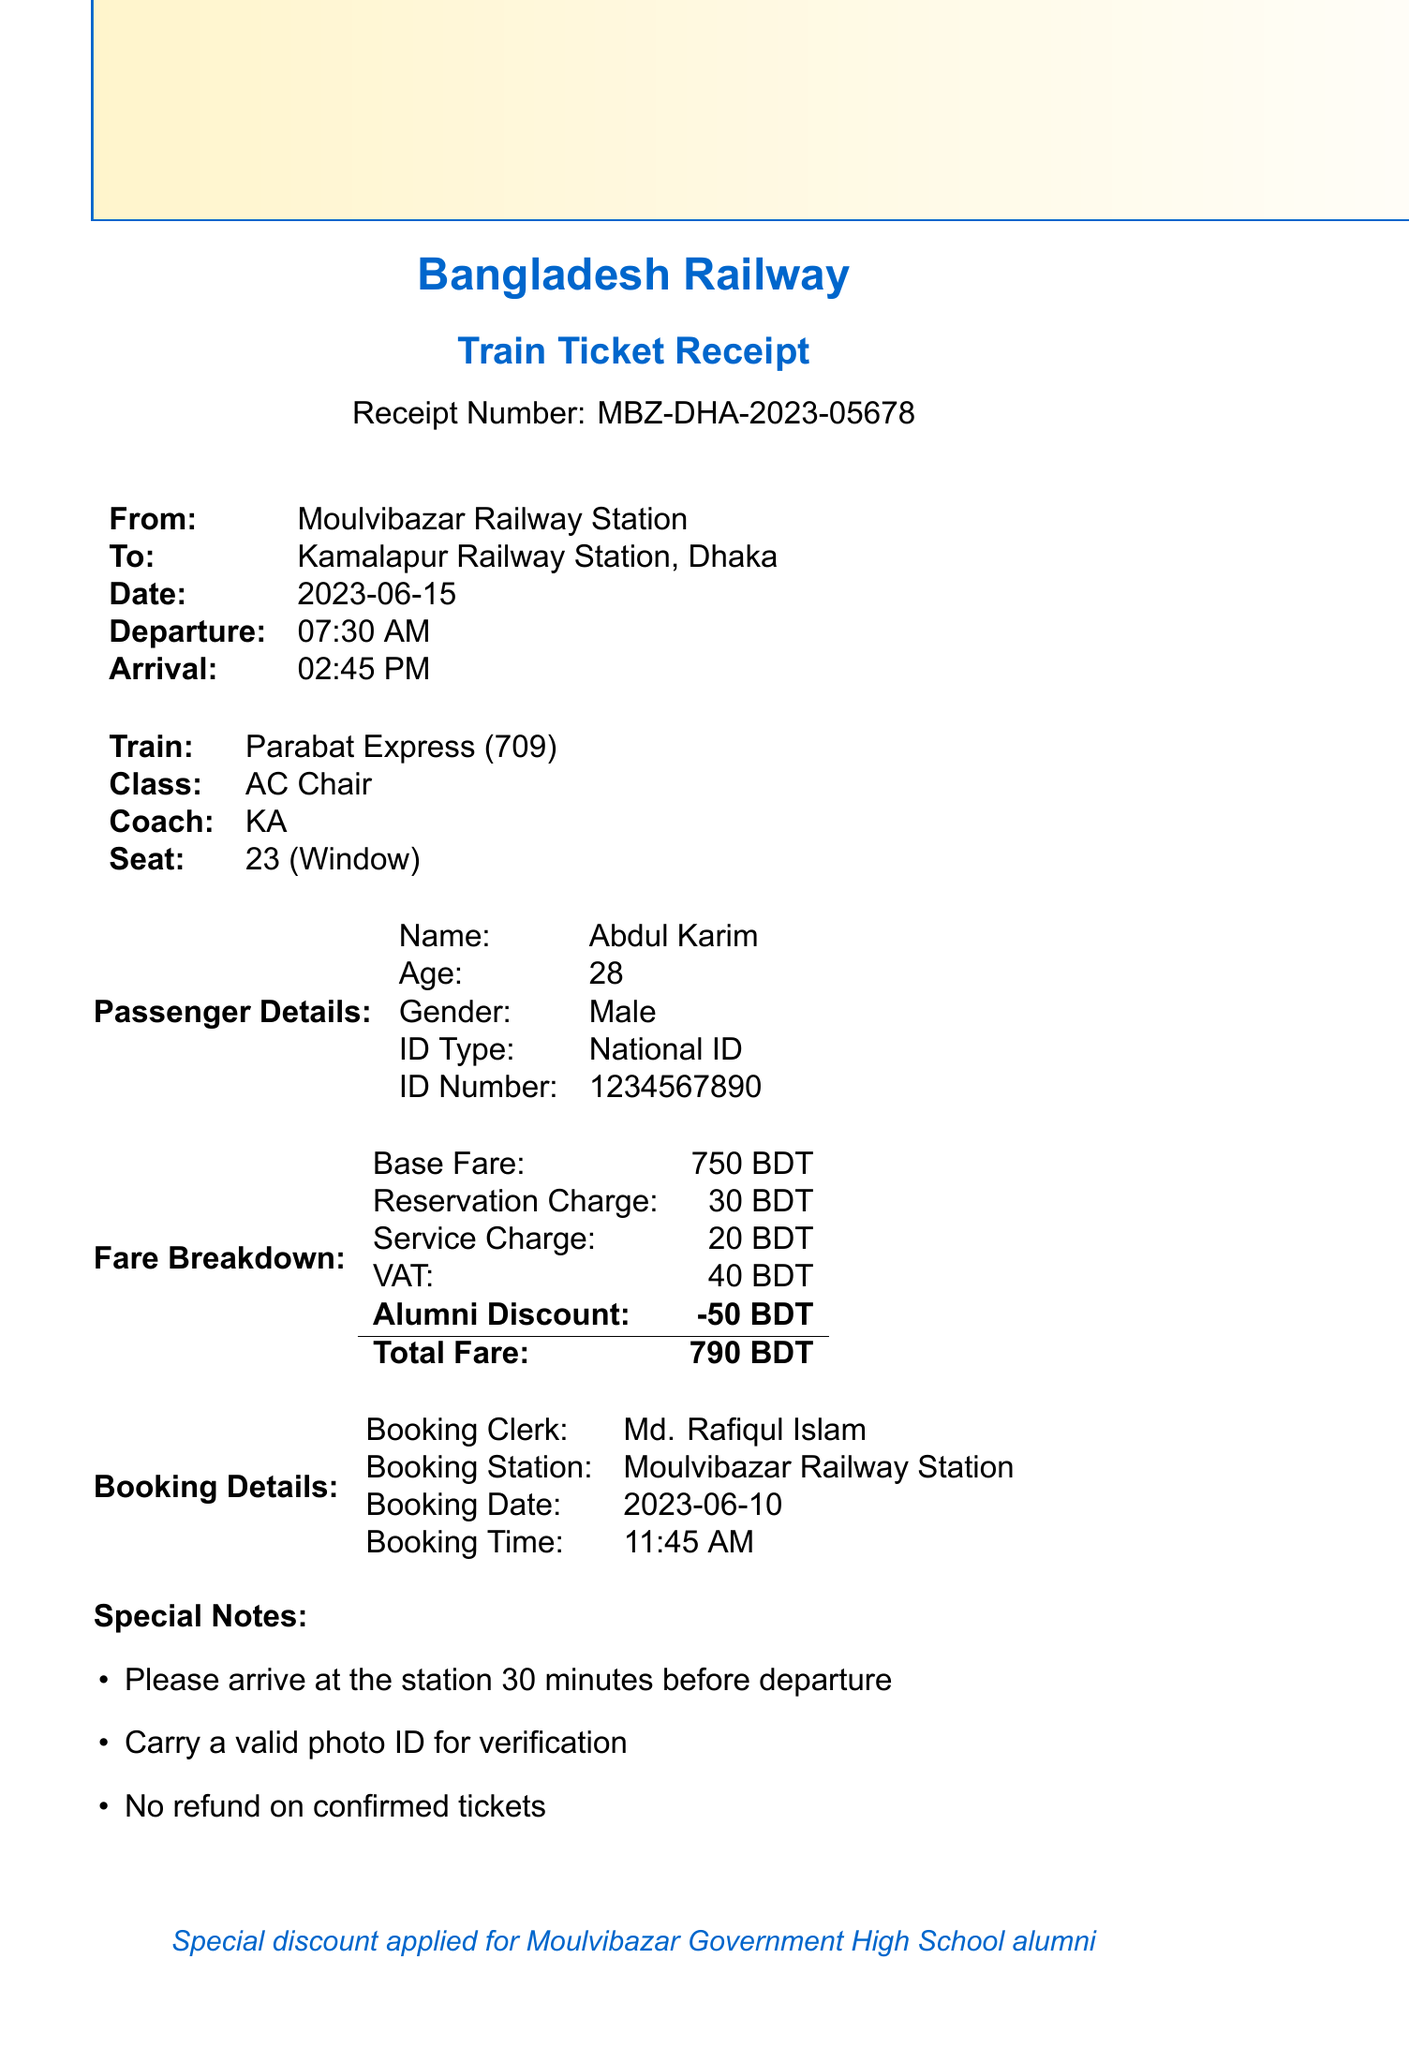What is the receipt number? The receipt number is a unique identifier for this ticket, which helps in tracking and referencing the transaction.
Answer: MBZ-DHA-2023-05678 What is the total fare? The total fare is the final amount charged to the passenger after applying all relevant charges and discounts.
Answer: 790 BDT Who is the booking clerk? The booking clerk is the person who facilitated the ticket purchase and recorded the details.
Answer: Md. Rafiqul Islam What is the journey date? The journey date indicates when the passenger is scheduled to travel from the departure station to the arrival station.
Answer: 2023-06-15 What train service is used for this journey? The train service details provide information about the specific train the passenger will use for travel.
Answer: Parabat Express Why was a discount applied? A discount is provided to encourage loyalty among specific groups, such as alumni of a school.
Answer: Special discount for Moulvibazar Government High School alumni What class of ticket was booked? The class of ticket indicates the level of comfort and amenities provided on the train.
Answer: AC Chair What time does the train depart? The departure time is crucial for passengers to know when they should arrive at the station.
Answer: 07:30 AM What is the seat number? The seat number is essential for passengers to know their allocated space on the train.
Answer: 23 